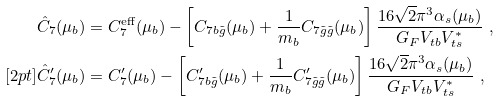<formula> <loc_0><loc_0><loc_500><loc_500>\hat { C } _ { 7 } ( \mu _ { b } ) & = C _ { 7 } ^ { \text {eff} } ( \mu _ { b } ) - \left [ C _ { 7 b \tilde { g } } ( \mu _ { b } ) + \frac { 1 } { m _ { b } } C _ { 7 \tilde { g } \tilde { g } } ( \mu _ { b } ) \right ] \frac { 1 6 \sqrt { 2 } \pi ^ { 3 } \alpha _ { s } ( \mu _ { b } ) } { G _ { F } V _ { t b } V _ { t s } ^ { \ast } } \ , \\ [ 2 p t ] \hat { C } _ { 7 } ^ { \prime } ( \mu _ { b } ) & = C _ { 7 } ^ { \prime } ( \mu _ { b } ) - \left [ C _ { 7 b \tilde { g } } ^ { \prime } ( \mu _ { b } ) + \frac { 1 } { m _ { b } } C _ { 7 \tilde { g } \tilde { g } } ^ { \prime } ( \mu _ { b } ) \right ] \frac { 1 6 \sqrt { 2 } \pi ^ { 3 } \alpha _ { s } ( \mu _ { b } ) } { G _ { F } V _ { t b } V ^ { \ast } _ { t s } } \ ,</formula> 